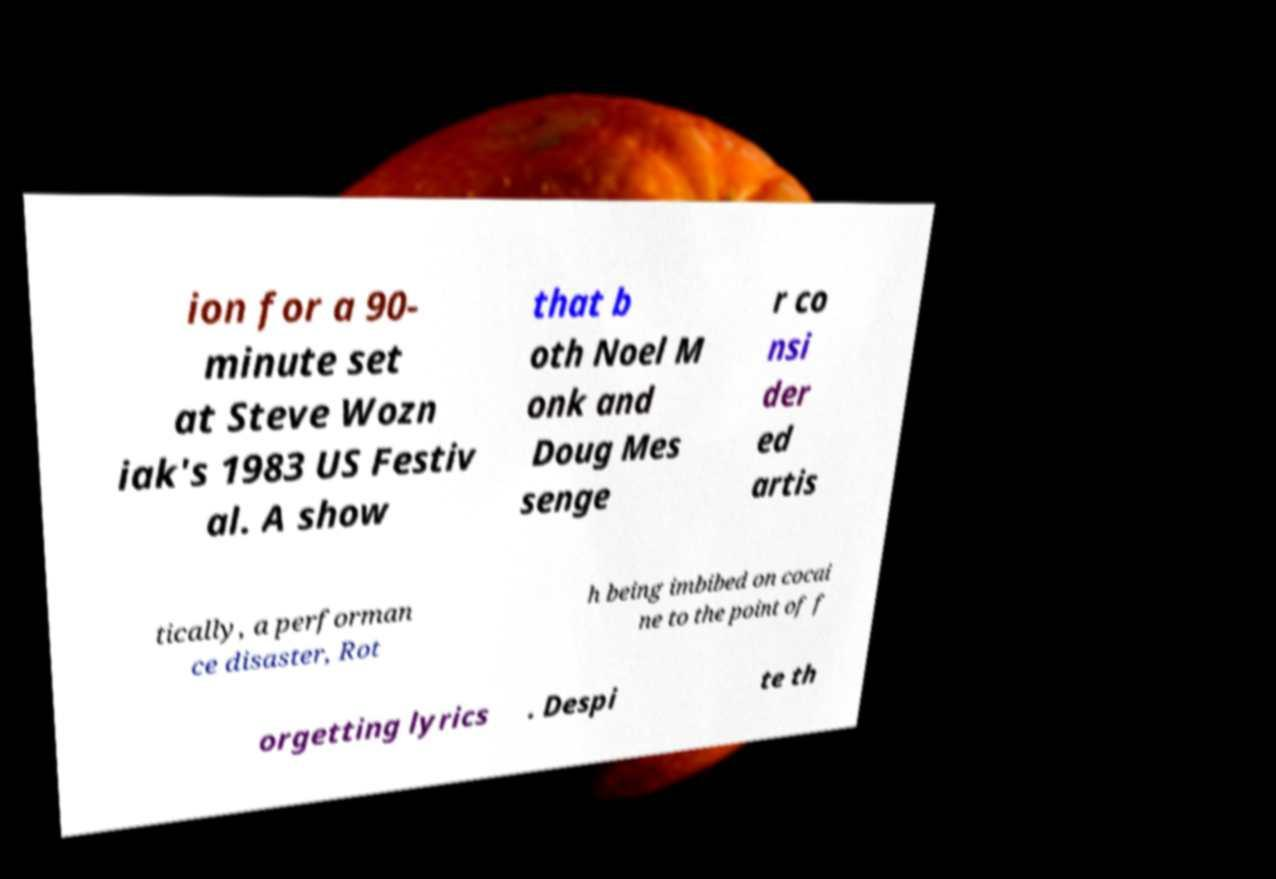Could you extract and type out the text from this image? ion for a 90- minute set at Steve Wozn iak's 1983 US Festiv al. A show that b oth Noel M onk and Doug Mes senge r co nsi der ed artis tically, a performan ce disaster, Rot h being imbibed on cocai ne to the point of f orgetting lyrics . Despi te th 